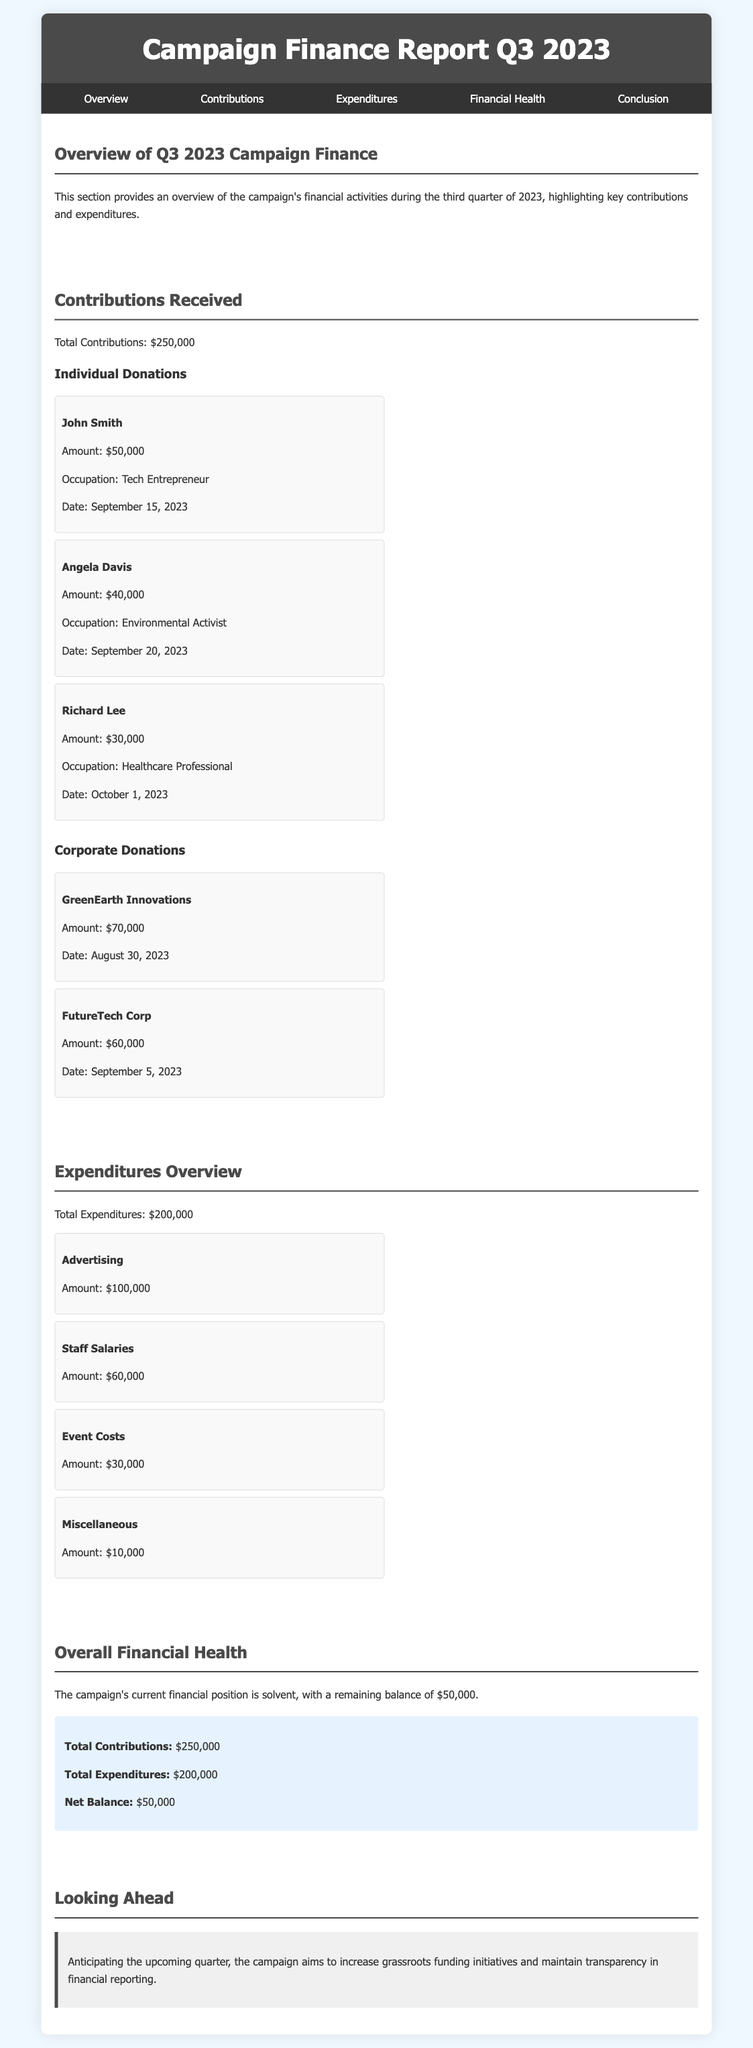What is the total contributions amount? The total contributions amount shows the cumulative sum of all contributions received during Q3 2023, which is stated in the document.
Answer: $250,000 Who made the largest individual donation? The document lists individual donations, highlighting the donor with the highest amount as part of the contributions overview.
Answer: John Smith What was the expenditure on advertising? The document details expenditures made by the campaign, emphasizing specific amounts for different categories, including advertising.
Answer: $100,000 What is the net balance of the campaign? The net balance is calculated by subtracting total expenditures from total contributions, a key metric mentioned in the financial health section.
Answer: $50,000 Which corporate entity contributed $70,000? The document provides a list of corporate donations with specific amounts, identifying the contributor associated with the $70,000 contribution.
Answer: GreenEarth Innovations What was the total expenditure amount? The total expenditure amount summarizes all spending by the campaign in the report.
Answer: $200,000 What amount was spent on staff salaries? The expenditures section provides detailed amounts spent on various categories, including staff salaries.
Answer: $60,000 In what quarter does this finance report cover? The document title specifies the time period that the report pertains to, indicating which quarter is being addressed.
Answer: Q3 2023 What is the main aim for the upcoming quarter mentioned in the conclusion? The conclusion outlines future intentions of the campaign, focusing on initiatives and goals for the next quarter.
Answer: Increase grassroots funding initiatives 